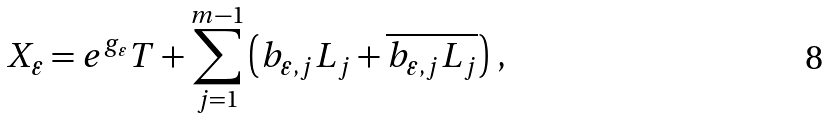Convert formula to latex. <formula><loc_0><loc_0><loc_500><loc_500>X _ { \varepsilon } = e ^ { g _ { \varepsilon } } T + \sum _ { j = 1 } ^ { m - 1 } \left ( b _ { \varepsilon , j } L _ { j } + \overline { b _ { \varepsilon , j } L _ { j } } \right ) \, ,</formula> 